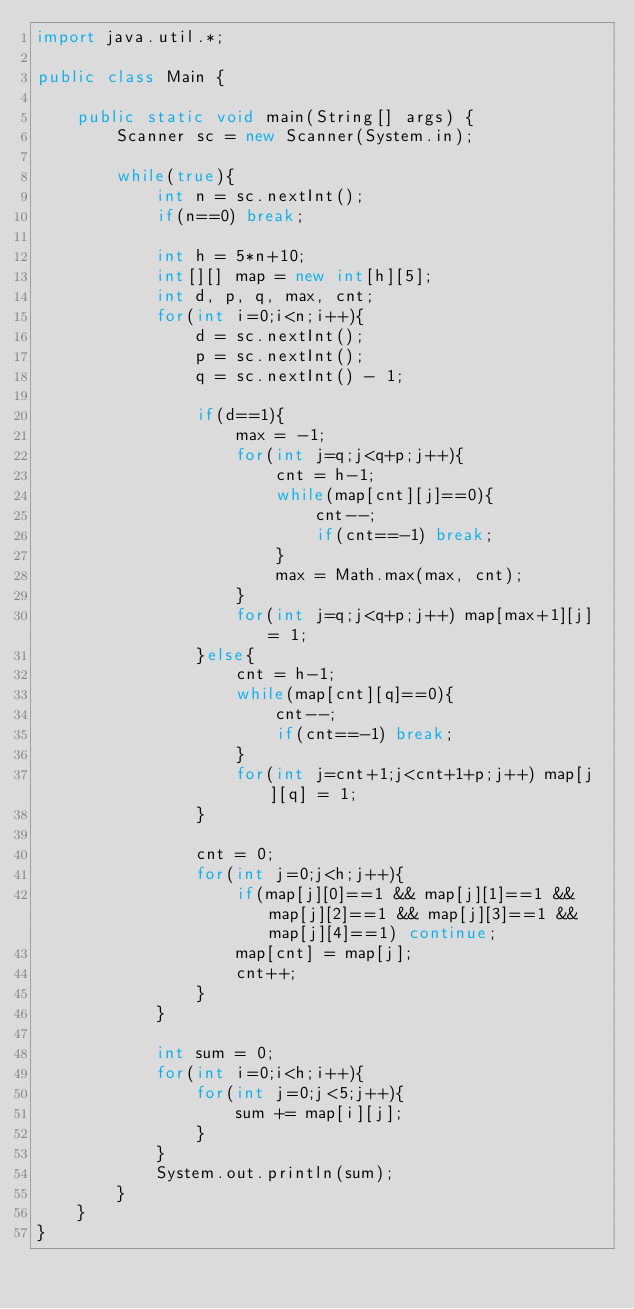<code> <loc_0><loc_0><loc_500><loc_500><_Java_>import java.util.*;

public class Main {
	
	public static void main(String[] args) {
		Scanner sc = new Scanner(System.in);
		
		while(true){
			int n = sc.nextInt();
			if(n==0) break;
			
			int h = 5*n+10;
			int[][] map = new int[h][5];
			int d, p, q, max, cnt;
			for(int i=0;i<n;i++){
				d = sc.nextInt();
				p = sc.nextInt();
				q = sc.nextInt() - 1; 
				
				if(d==1){
					max = -1;
					for(int j=q;j<q+p;j++){
						cnt = h-1;
						while(map[cnt][j]==0){
							cnt--;
							if(cnt==-1) break;
						}
						max = Math.max(max, cnt);
					}
					for(int j=q;j<q+p;j++) map[max+1][j] = 1;
				}else{
					cnt = h-1;
					while(map[cnt][q]==0){
						cnt--;
						if(cnt==-1) break;
					}
					for(int j=cnt+1;j<cnt+1+p;j++) map[j][q] = 1;
				}
				
				cnt = 0;
				for(int j=0;j<h;j++){
					if(map[j][0]==1 && map[j][1]==1 && map[j][2]==1 && map[j][3]==1 && map[j][4]==1) continue;
					map[cnt] = map[j];
					cnt++;
				}
			}
			
			int sum = 0;
			for(int i=0;i<h;i++){
				for(int j=0;j<5;j++){
					sum += map[i][j];
				}
			}
			System.out.println(sum);
		}	
	}	
}</code> 